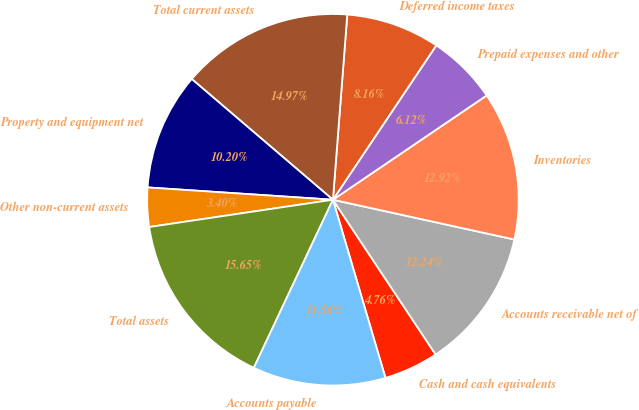Convert chart to OTSL. <chart><loc_0><loc_0><loc_500><loc_500><pie_chart><fcel>Cash and cash equivalents<fcel>Accounts receivable net of<fcel>Inventories<fcel>Prepaid expenses and other<fcel>Deferred income taxes<fcel>Total current assets<fcel>Property and equipment net<fcel>Other non-current assets<fcel>Total assets<fcel>Accounts payable<nl><fcel>4.76%<fcel>12.24%<fcel>12.92%<fcel>6.12%<fcel>8.16%<fcel>14.97%<fcel>10.2%<fcel>3.4%<fcel>15.65%<fcel>11.56%<nl></chart> 